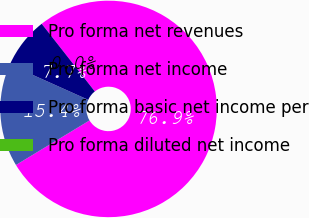<chart> <loc_0><loc_0><loc_500><loc_500><pie_chart><fcel>Pro forma net revenues<fcel>Pro forma net income<fcel>Pro forma basic net income per<fcel>Pro forma diluted net income<nl><fcel>76.92%<fcel>15.38%<fcel>7.69%<fcel>0.0%<nl></chart> 